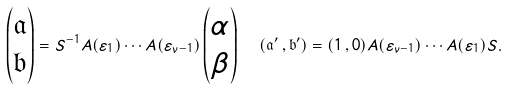Convert formula to latex. <formula><loc_0><loc_0><loc_500><loc_500>\left ( \begin{matrix} \mathfrak { a } \\ \mathfrak { b } \end{matrix} \right ) = S ^ { - 1 } A ( \varepsilon _ { 1 } ) \cdots A ( \varepsilon _ { \nu - 1 } ) \left ( \begin{matrix} \alpha \\ \beta \end{matrix} \right ) \ \ ( \mathfrak a ^ { \prime } \, , \mathfrak b ^ { \prime } ) = ( 1 \, , 0 ) A ( \varepsilon _ { \nu - 1 } ) \cdots A ( \varepsilon _ { 1 } ) S .</formula> 